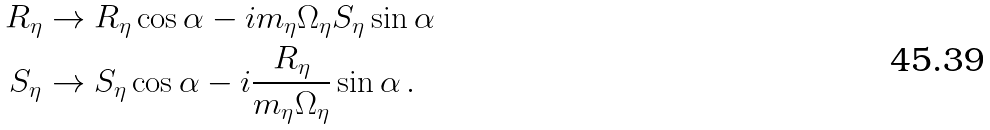Convert formula to latex. <formula><loc_0><loc_0><loc_500><loc_500>R _ { \eta } & \to R _ { \eta } \cos \alpha - i m _ { \eta } \Omega _ { \eta } S _ { \eta } \sin \alpha \\ S _ { \eta } & \to S _ { \eta } \cos \alpha - i \frac { R _ { \eta } } { m _ { \eta } \Omega _ { \eta } } \sin \alpha \, .</formula> 